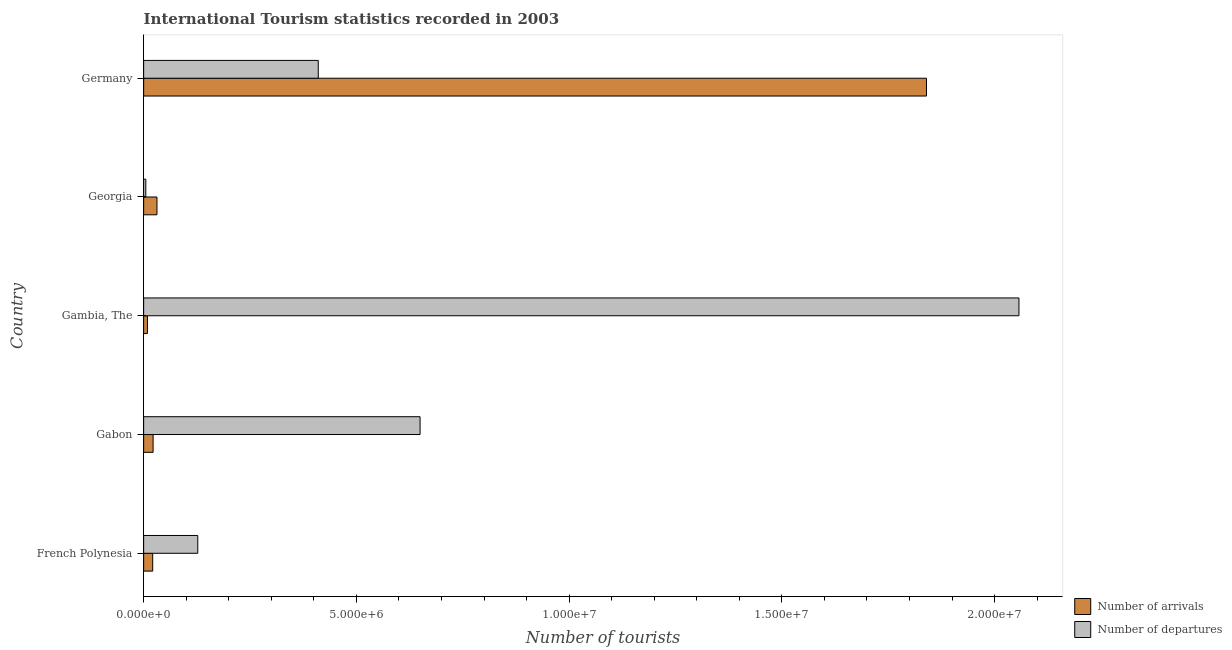How many different coloured bars are there?
Keep it short and to the point. 2. Are the number of bars per tick equal to the number of legend labels?
Your answer should be compact. Yes. Are the number of bars on each tick of the Y-axis equal?
Ensure brevity in your answer.  Yes. How many bars are there on the 3rd tick from the top?
Provide a short and direct response. 2. What is the label of the 1st group of bars from the top?
Give a very brief answer. Germany. What is the number of tourist departures in Germany?
Ensure brevity in your answer.  4.10e+06. Across all countries, what is the maximum number of tourist departures?
Give a very brief answer. 2.06e+07. Across all countries, what is the minimum number of tourist arrivals?
Your response must be concise. 8.90e+04. In which country was the number of tourist departures maximum?
Make the answer very short. Gambia, The. In which country was the number of tourist arrivals minimum?
Offer a very short reply. Gambia, The. What is the total number of tourist arrivals in the graph?
Make the answer very short. 1.92e+07. What is the difference between the number of tourist arrivals in French Polynesia and that in Gabon?
Provide a short and direct response. -9000. What is the difference between the number of tourist departures in Georgia and the number of tourist arrivals in Germany?
Offer a terse response. -1.83e+07. What is the average number of tourist arrivals per country?
Provide a short and direct response. 3.85e+06. What is the difference between the number of tourist arrivals and number of tourist departures in Gabon?
Make the answer very short. -6.28e+06. What is the ratio of the number of tourist arrivals in French Polynesia to that in Georgia?
Ensure brevity in your answer.  0.68. Is the number of tourist departures in French Polynesia less than that in Gabon?
Your answer should be very brief. Yes. Is the difference between the number of tourist arrivals in Gabon and Germany greater than the difference between the number of tourist departures in Gabon and Germany?
Provide a succinct answer. No. What is the difference between the highest and the second highest number of tourist departures?
Your response must be concise. 1.41e+07. What is the difference between the highest and the lowest number of tourist departures?
Provide a short and direct response. 2.05e+07. Is the sum of the number of tourist arrivals in French Polynesia and Gabon greater than the maximum number of tourist departures across all countries?
Offer a terse response. No. What does the 1st bar from the top in Germany represents?
Keep it short and to the point. Number of departures. What does the 2nd bar from the bottom in Georgia represents?
Your answer should be very brief. Number of departures. Are all the bars in the graph horizontal?
Your response must be concise. Yes. How many countries are there in the graph?
Offer a very short reply. 5. Are the values on the major ticks of X-axis written in scientific E-notation?
Keep it short and to the point. Yes. Does the graph contain grids?
Provide a succinct answer. No. How are the legend labels stacked?
Provide a short and direct response. Vertical. What is the title of the graph?
Give a very brief answer. International Tourism statistics recorded in 2003. What is the label or title of the X-axis?
Your response must be concise. Number of tourists. What is the label or title of the Y-axis?
Give a very brief answer. Country. What is the Number of tourists of Number of arrivals in French Polynesia?
Keep it short and to the point. 2.13e+05. What is the Number of tourists of Number of departures in French Polynesia?
Keep it short and to the point. 1.27e+06. What is the Number of tourists in Number of arrivals in Gabon?
Your answer should be compact. 2.22e+05. What is the Number of tourists in Number of departures in Gabon?
Keep it short and to the point. 6.50e+06. What is the Number of tourists of Number of arrivals in Gambia, The?
Your answer should be compact. 8.90e+04. What is the Number of tourists in Number of departures in Gambia, The?
Offer a very short reply. 2.06e+07. What is the Number of tourists of Number of arrivals in Georgia?
Offer a terse response. 3.13e+05. What is the Number of tourists in Number of departures in Georgia?
Ensure brevity in your answer.  5.10e+04. What is the Number of tourists in Number of arrivals in Germany?
Your answer should be compact. 1.84e+07. What is the Number of tourists in Number of departures in Germany?
Offer a very short reply. 4.10e+06. Across all countries, what is the maximum Number of tourists in Number of arrivals?
Give a very brief answer. 1.84e+07. Across all countries, what is the maximum Number of tourists of Number of departures?
Ensure brevity in your answer.  2.06e+07. Across all countries, what is the minimum Number of tourists in Number of arrivals?
Your answer should be compact. 8.90e+04. Across all countries, what is the minimum Number of tourists in Number of departures?
Your answer should be very brief. 5.10e+04. What is the total Number of tourists of Number of arrivals in the graph?
Ensure brevity in your answer.  1.92e+07. What is the total Number of tourists of Number of departures in the graph?
Give a very brief answer. 3.25e+07. What is the difference between the Number of tourists in Number of arrivals in French Polynesia and that in Gabon?
Provide a short and direct response. -9000. What is the difference between the Number of tourists of Number of departures in French Polynesia and that in Gabon?
Your answer should be very brief. -5.22e+06. What is the difference between the Number of tourists of Number of arrivals in French Polynesia and that in Gambia, The?
Give a very brief answer. 1.24e+05. What is the difference between the Number of tourists of Number of departures in French Polynesia and that in Gambia, The?
Your answer should be compact. -1.93e+07. What is the difference between the Number of tourists of Number of departures in French Polynesia and that in Georgia?
Offer a very short reply. 1.22e+06. What is the difference between the Number of tourists of Number of arrivals in French Polynesia and that in Germany?
Offer a terse response. -1.82e+07. What is the difference between the Number of tourists in Number of departures in French Polynesia and that in Germany?
Your answer should be compact. -2.83e+06. What is the difference between the Number of tourists of Number of arrivals in Gabon and that in Gambia, The?
Your answer should be compact. 1.33e+05. What is the difference between the Number of tourists of Number of departures in Gabon and that in Gambia, The?
Provide a succinct answer. -1.41e+07. What is the difference between the Number of tourists in Number of arrivals in Gabon and that in Georgia?
Provide a short and direct response. -9.10e+04. What is the difference between the Number of tourists of Number of departures in Gabon and that in Georgia?
Ensure brevity in your answer.  6.45e+06. What is the difference between the Number of tourists in Number of arrivals in Gabon and that in Germany?
Offer a terse response. -1.82e+07. What is the difference between the Number of tourists of Number of departures in Gabon and that in Germany?
Your answer should be compact. 2.39e+06. What is the difference between the Number of tourists in Number of arrivals in Gambia, The and that in Georgia?
Provide a short and direct response. -2.24e+05. What is the difference between the Number of tourists in Number of departures in Gambia, The and that in Georgia?
Your response must be concise. 2.05e+07. What is the difference between the Number of tourists of Number of arrivals in Gambia, The and that in Germany?
Your answer should be very brief. -1.83e+07. What is the difference between the Number of tourists in Number of departures in Gambia, The and that in Germany?
Ensure brevity in your answer.  1.65e+07. What is the difference between the Number of tourists of Number of arrivals in Georgia and that in Germany?
Provide a succinct answer. -1.81e+07. What is the difference between the Number of tourists of Number of departures in Georgia and that in Germany?
Make the answer very short. -4.05e+06. What is the difference between the Number of tourists of Number of arrivals in French Polynesia and the Number of tourists of Number of departures in Gabon?
Your answer should be very brief. -6.28e+06. What is the difference between the Number of tourists in Number of arrivals in French Polynesia and the Number of tourists in Number of departures in Gambia, The?
Ensure brevity in your answer.  -2.04e+07. What is the difference between the Number of tourists of Number of arrivals in French Polynesia and the Number of tourists of Number of departures in Georgia?
Make the answer very short. 1.62e+05. What is the difference between the Number of tourists in Number of arrivals in French Polynesia and the Number of tourists in Number of departures in Germany?
Give a very brief answer. -3.89e+06. What is the difference between the Number of tourists in Number of arrivals in Gabon and the Number of tourists in Number of departures in Gambia, The?
Provide a succinct answer. -2.04e+07. What is the difference between the Number of tourists in Number of arrivals in Gabon and the Number of tourists in Number of departures in Georgia?
Offer a very short reply. 1.71e+05. What is the difference between the Number of tourists of Number of arrivals in Gabon and the Number of tourists of Number of departures in Germany?
Your response must be concise. -3.88e+06. What is the difference between the Number of tourists in Number of arrivals in Gambia, The and the Number of tourists in Number of departures in Georgia?
Your answer should be very brief. 3.80e+04. What is the difference between the Number of tourists in Number of arrivals in Gambia, The and the Number of tourists in Number of departures in Germany?
Your answer should be compact. -4.02e+06. What is the difference between the Number of tourists in Number of arrivals in Georgia and the Number of tourists in Number of departures in Germany?
Your answer should be very brief. -3.79e+06. What is the average Number of tourists of Number of arrivals per country?
Offer a very short reply. 3.85e+06. What is the average Number of tourists in Number of departures per country?
Keep it short and to the point. 6.50e+06. What is the difference between the Number of tourists of Number of arrivals and Number of tourists of Number of departures in French Polynesia?
Give a very brief answer. -1.06e+06. What is the difference between the Number of tourists in Number of arrivals and Number of tourists in Number of departures in Gabon?
Provide a short and direct response. -6.28e+06. What is the difference between the Number of tourists of Number of arrivals and Number of tourists of Number of departures in Gambia, The?
Offer a terse response. -2.05e+07. What is the difference between the Number of tourists in Number of arrivals and Number of tourists in Number of departures in Georgia?
Your response must be concise. 2.62e+05. What is the difference between the Number of tourists in Number of arrivals and Number of tourists in Number of departures in Germany?
Your response must be concise. 1.43e+07. What is the ratio of the Number of tourists of Number of arrivals in French Polynesia to that in Gabon?
Your answer should be very brief. 0.96. What is the ratio of the Number of tourists in Number of departures in French Polynesia to that in Gabon?
Your answer should be compact. 0.2. What is the ratio of the Number of tourists of Number of arrivals in French Polynesia to that in Gambia, The?
Your answer should be compact. 2.39. What is the ratio of the Number of tourists in Number of departures in French Polynesia to that in Gambia, The?
Your response must be concise. 0.06. What is the ratio of the Number of tourists in Number of arrivals in French Polynesia to that in Georgia?
Offer a very short reply. 0.68. What is the ratio of the Number of tourists of Number of departures in French Polynesia to that in Georgia?
Give a very brief answer. 24.94. What is the ratio of the Number of tourists in Number of arrivals in French Polynesia to that in Germany?
Your answer should be very brief. 0.01. What is the ratio of the Number of tourists of Number of departures in French Polynesia to that in Germany?
Keep it short and to the point. 0.31. What is the ratio of the Number of tourists in Number of arrivals in Gabon to that in Gambia, The?
Make the answer very short. 2.49. What is the ratio of the Number of tourists in Number of departures in Gabon to that in Gambia, The?
Offer a very short reply. 0.32. What is the ratio of the Number of tourists of Number of arrivals in Gabon to that in Georgia?
Provide a succinct answer. 0.71. What is the ratio of the Number of tourists in Number of departures in Gabon to that in Georgia?
Your answer should be compact. 127.39. What is the ratio of the Number of tourists of Number of arrivals in Gabon to that in Germany?
Your answer should be compact. 0.01. What is the ratio of the Number of tourists in Number of departures in Gabon to that in Germany?
Offer a terse response. 1.58. What is the ratio of the Number of tourists in Number of arrivals in Gambia, The to that in Georgia?
Provide a short and direct response. 0.28. What is the ratio of the Number of tourists in Number of departures in Gambia, The to that in Georgia?
Keep it short and to the point. 403.37. What is the ratio of the Number of tourists in Number of arrivals in Gambia, The to that in Germany?
Make the answer very short. 0. What is the ratio of the Number of tourists of Number of departures in Gambia, The to that in Germany?
Your answer should be compact. 5.01. What is the ratio of the Number of tourists of Number of arrivals in Georgia to that in Germany?
Your answer should be compact. 0.02. What is the ratio of the Number of tourists in Number of departures in Georgia to that in Germany?
Make the answer very short. 0.01. What is the difference between the highest and the second highest Number of tourists of Number of arrivals?
Ensure brevity in your answer.  1.81e+07. What is the difference between the highest and the second highest Number of tourists in Number of departures?
Keep it short and to the point. 1.41e+07. What is the difference between the highest and the lowest Number of tourists of Number of arrivals?
Your response must be concise. 1.83e+07. What is the difference between the highest and the lowest Number of tourists in Number of departures?
Keep it short and to the point. 2.05e+07. 